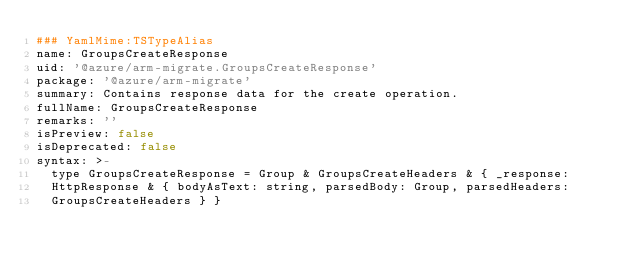Convert code to text. <code><loc_0><loc_0><loc_500><loc_500><_YAML_>### YamlMime:TSTypeAlias
name: GroupsCreateResponse
uid: '@azure/arm-migrate.GroupsCreateResponse'
package: '@azure/arm-migrate'
summary: Contains response data for the create operation.
fullName: GroupsCreateResponse
remarks: ''
isPreview: false
isDeprecated: false
syntax: >-
  type GroupsCreateResponse = Group & GroupsCreateHeaders & { _response:
  HttpResponse & { bodyAsText: string, parsedBody: Group, parsedHeaders:
  GroupsCreateHeaders } }
</code> 